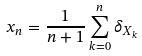<formula> <loc_0><loc_0><loc_500><loc_500>x _ { n } = \frac { 1 } { n + 1 } \sum _ { k = 0 } ^ { n } \delta _ { X _ { k } }</formula> 